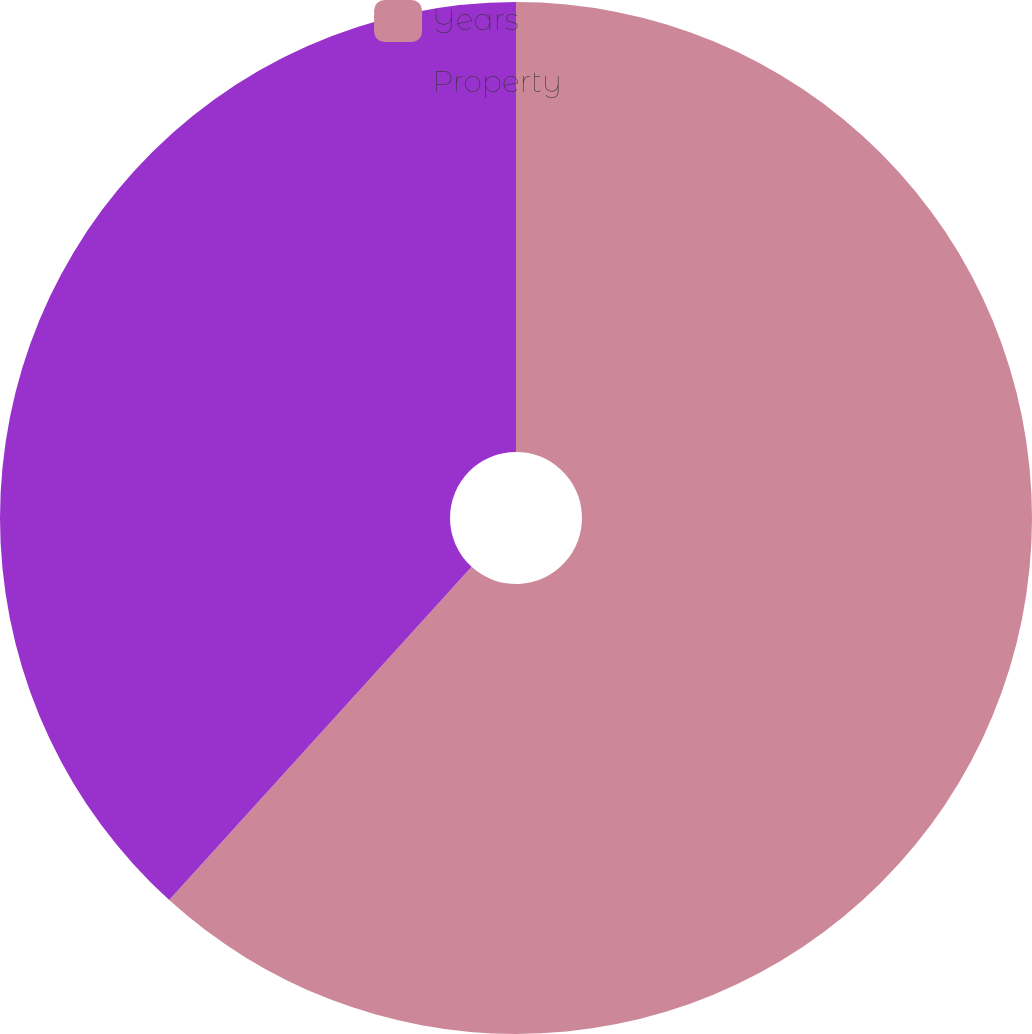<chart> <loc_0><loc_0><loc_500><loc_500><pie_chart><fcel>Years<fcel>Property<nl><fcel>61.73%<fcel>38.27%<nl></chart> 